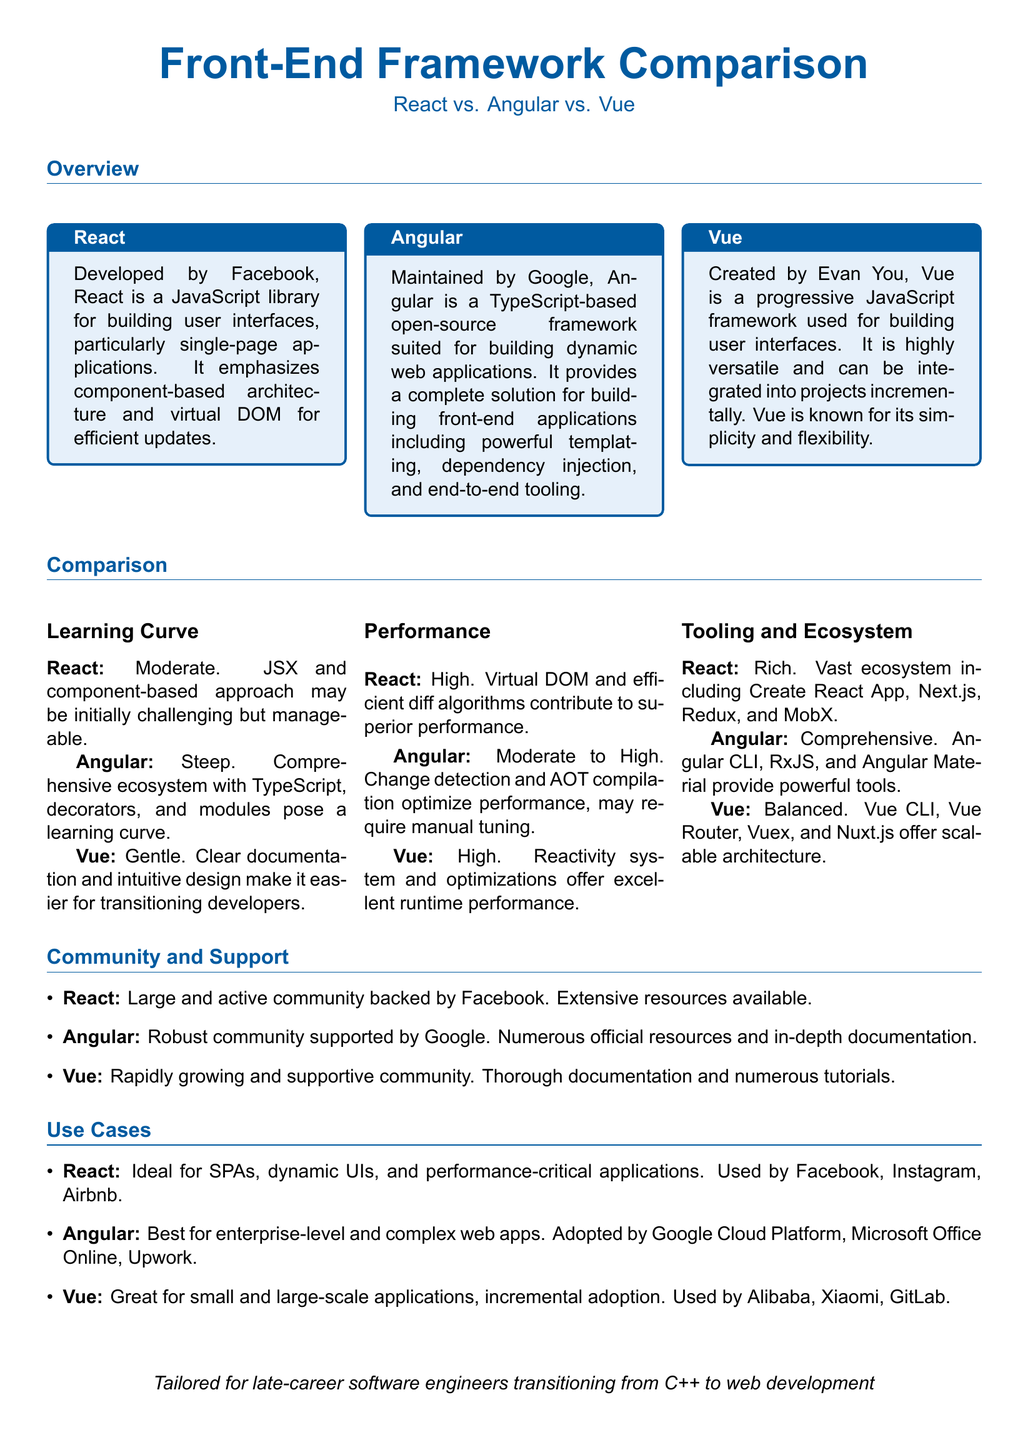What is React primarily used for? React is mainly used for building user interfaces, specifically single-page applications, as mentioned in the overview section.
Answer: user interfaces Who maintains Angular? The document states that Angular is maintained by Google, which is an important detail regarding its support and credibility.
Answer: Google Which framework is known for its gentle learning curve? The overview of the learning curves indicates that Vue is recognized for its gentle learning curve, making it easier for developers.
Answer: Vue What type of applications is Angular best suited for? According to the use cases section, Angular is described as being best for enterprise-level and complex web apps.
Answer: enterprise-level and complex web apps What is a primary advantage of React's performance? The comparison section highlights that React's performance is high due to its virtual DOM and efficient diff algorithms.
Answer: virtual DOM List one tool included in the React ecosystem. The document mentions several tools under React's tooling and ecosystem, one of which is Create React App.
Answer: Create React App Which framework has a rapidly growing community? The community and support section indicates that Vue has a rapidly growing and supportive community, distinguishing it from others.
Answer: Vue What is Angular's performance categorized as? The performance comparison for Angular categorizes its performance as moderate to high, outlining its efficiency levels.
Answer: moderate to high Which companies use Vue? The document cites companies like Alibaba, Xiaomi, and GitLab as users of Vue in the use cases section.
Answer: Alibaba, Xiaomi, GitLab 